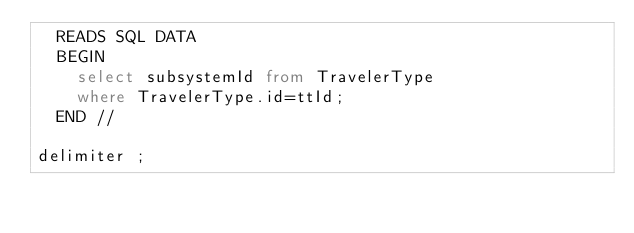Convert code to text. <code><loc_0><loc_0><loc_500><loc_500><_SQL_>  READS SQL DATA
  BEGIN
    select subsystemId from TravelerType 
    where TravelerType.id=ttId;
  END //

delimiter ;
</code> 